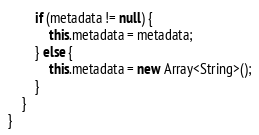<code> <loc_0><loc_0><loc_500><loc_500><_Haxe_>		if (metadata != null) {
			this.metadata = metadata;
		} else {
			this.metadata = new Array<String>();
		}
	}
}
</code> 